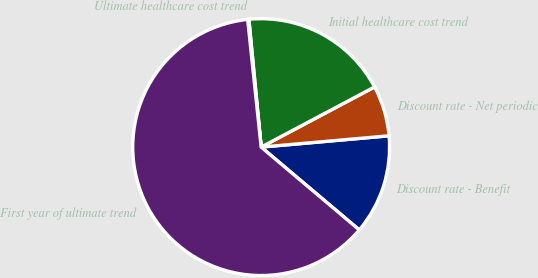<chart> <loc_0><loc_0><loc_500><loc_500><pie_chart><fcel>Discount rate - Benefit<fcel>Discount rate - Net periodic<fcel>Initial healthcare cost trend<fcel>Ultimate healthcare cost trend<fcel>First year of ultimate trend<nl><fcel>12.56%<fcel>6.36%<fcel>18.76%<fcel>0.15%<fcel>62.17%<nl></chart> 